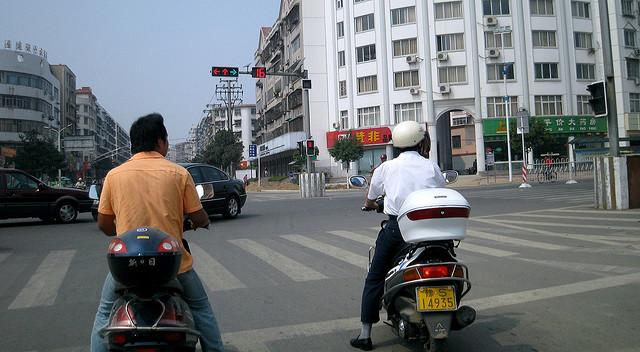What are the men riding?
Short answer required. Mopeds. Is the man wearing a helmet?
Quick response, please. Yes. Are the men looking at the cars in this picture?
Be succinct. No. Is the man on the right riding a motorcycle?
Be succinct. Yes. 